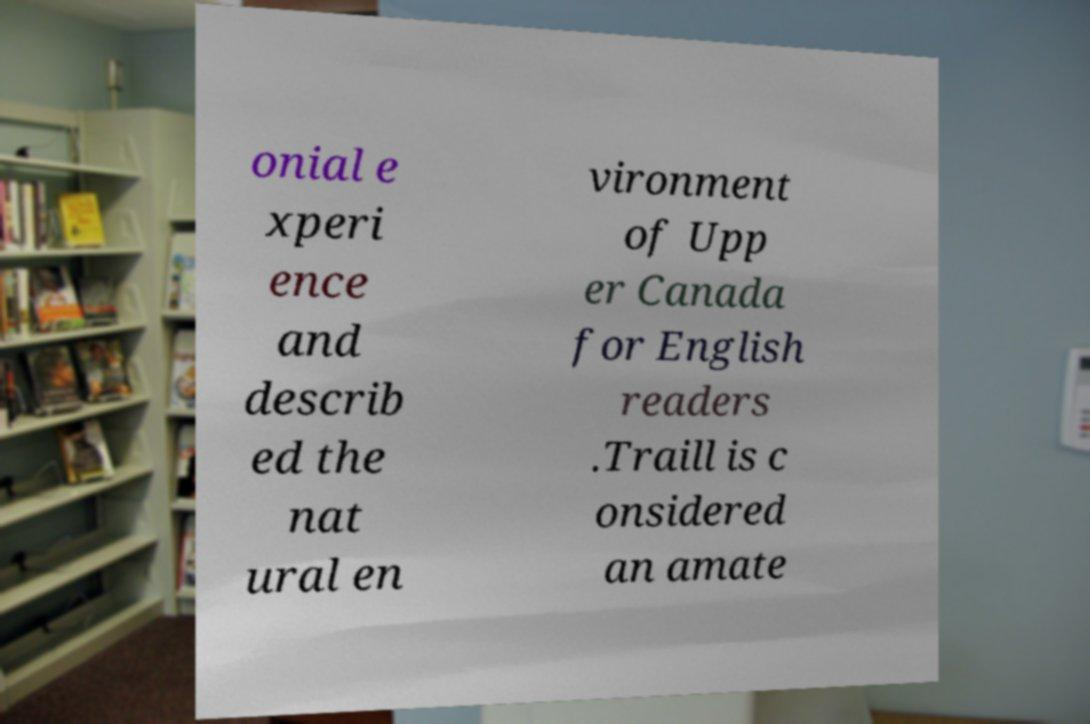Please identify and transcribe the text found in this image. onial e xperi ence and describ ed the nat ural en vironment of Upp er Canada for English readers .Traill is c onsidered an amate 